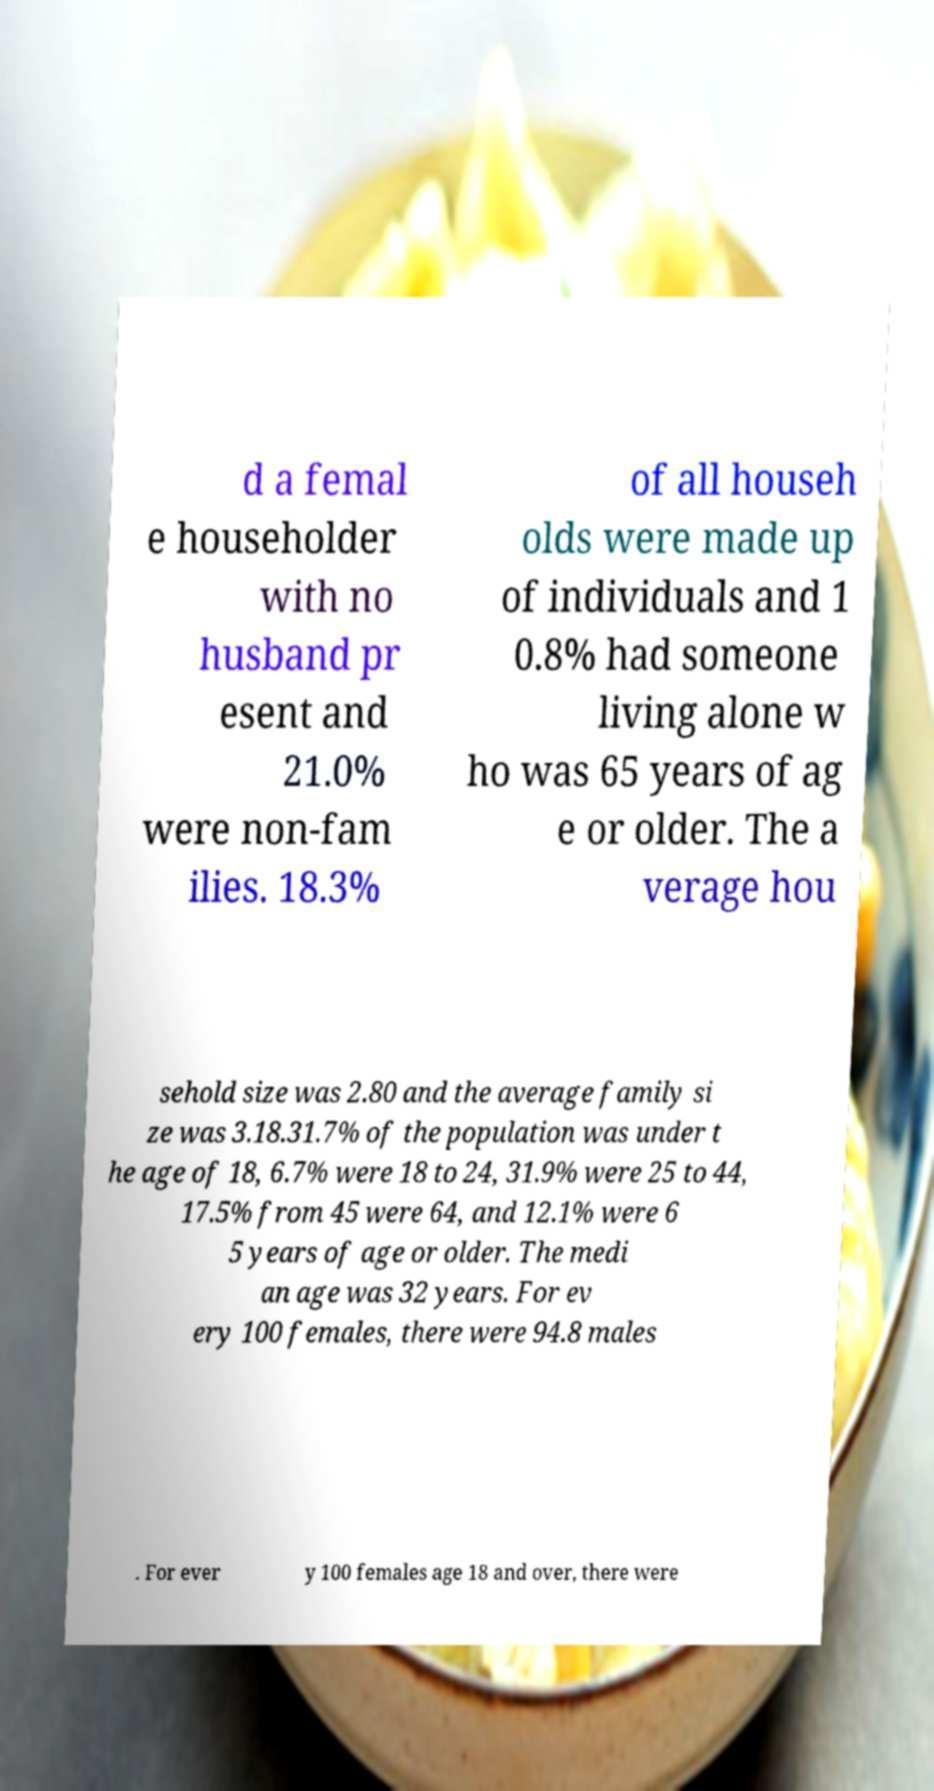Please read and relay the text visible in this image. What does it say? d a femal e householder with no husband pr esent and 21.0% were non-fam ilies. 18.3% of all househ olds were made up of individuals and 1 0.8% had someone living alone w ho was 65 years of ag e or older. The a verage hou sehold size was 2.80 and the average family si ze was 3.18.31.7% of the population was under t he age of 18, 6.7% were 18 to 24, 31.9% were 25 to 44, 17.5% from 45 were 64, and 12.1% were 6 5 years of age or older. The medi an age was 32 years. For ev ery 100 females, there were 94.8 males . For ever y 100 females age 18 and over, there were 